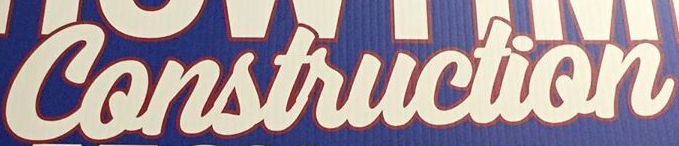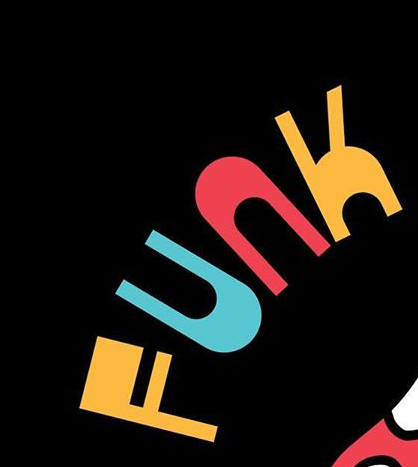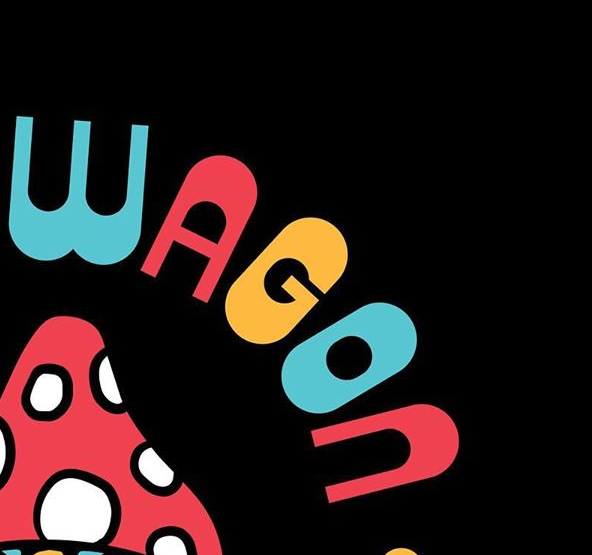Read the text from these images in sequence, separated by a semicolon. Construction; FUNK; WAGON 